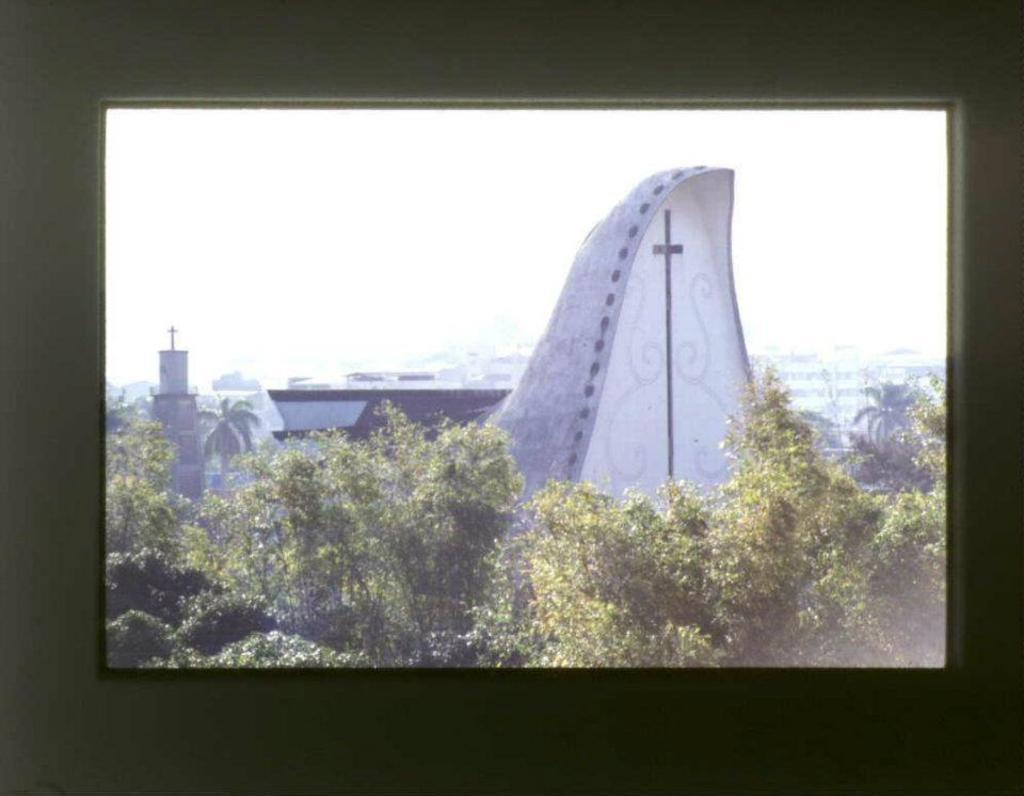What type of structures can be seen in the image? There are buildings in the image. What natural elements are present in the image? There are trees in the image. What religious symbols can be observed in the image? There are cross symbols in the image. What tall structure is visible in the image? There is a tower in the image. What part of the natural environment is visible in the image? The sky is visible in the image. What type of vegetable is being harvested in the image? There is no vegetable being harvested in the image; it features buildings, trees, cross symbols, a tower, and the sky. What type of skin condition can be seen on the people in the image? There are no people present in the image, so it is not possible to determine if any skin conditions are visible. 